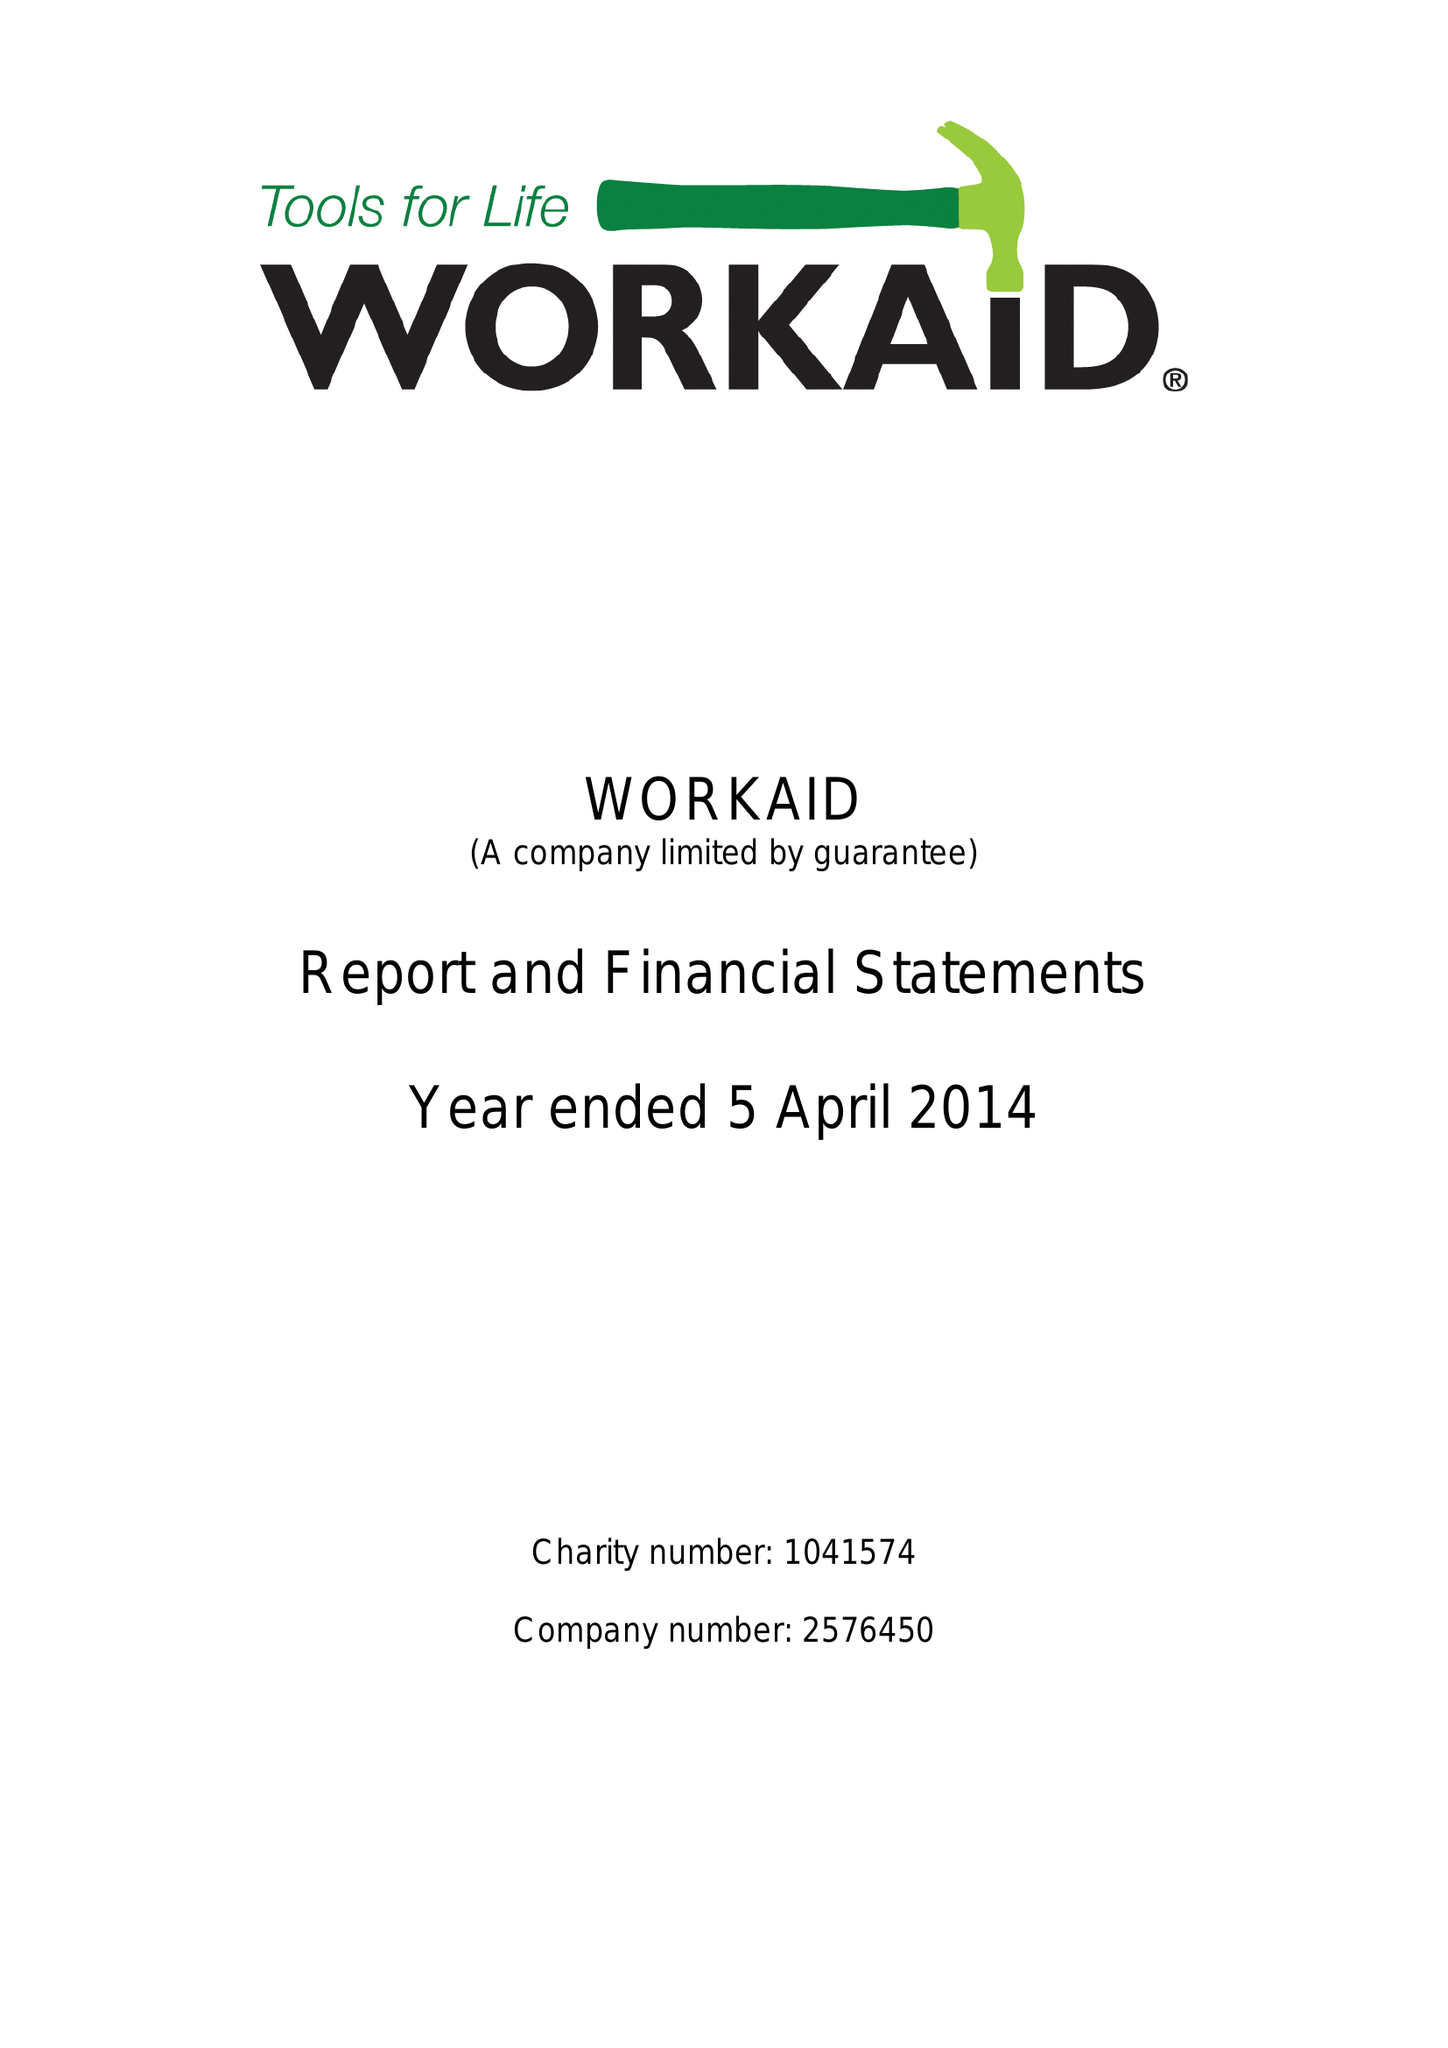What is the value for the charity_name?
Answer the question using a single word or phrase. Workaid 